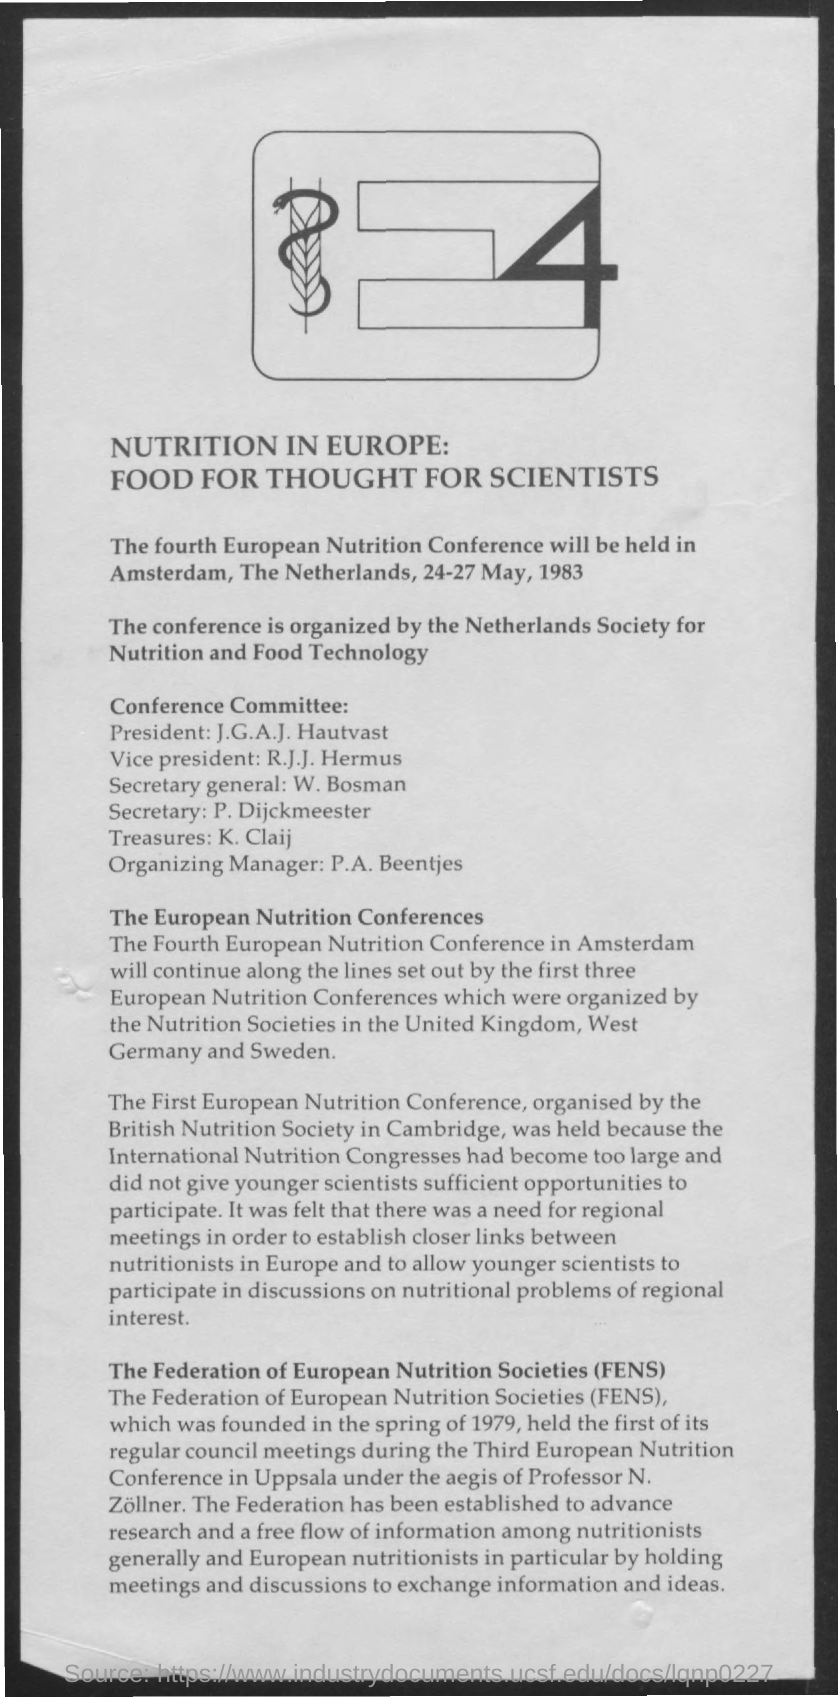When is the fourth European Nutrition Conference held?
Keep it short and to the point. 24-27 May, 1983. Who is the President of the Conference Committee?
Offer a terse response. J.G.A.J. Hautvast. Who is the Vice President of the Conference Committee?
Provide a succinct answer. R.j.j. hermus. Who is the Secretary General of the Conference  Committee?
Offer a terse response. W. Bosman. What is the fullform of FENS?
Your answer should be compact. The federation of european nutrition societies. 